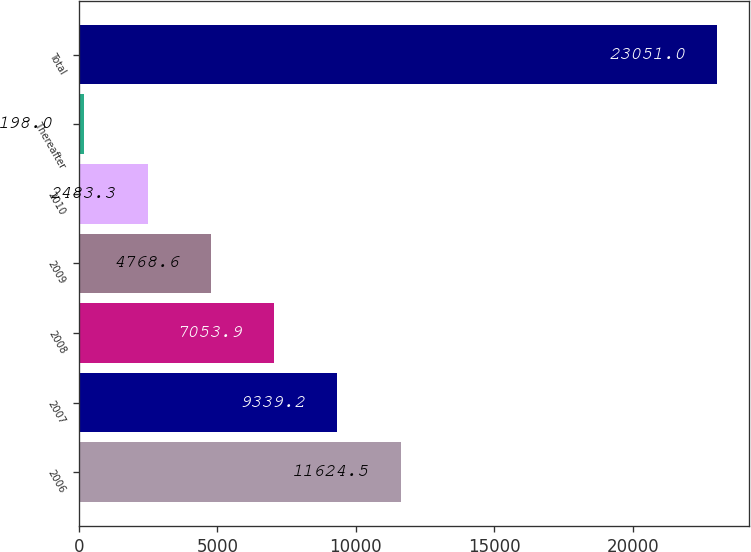<chart> <loc_0><loc_0><loc_500><loc_500><bar_chart><fcel>2006<fcel>2007<fcel>2008<fcel>2009<fcel>2010<fcel>Thereafter<fcel>Total<nl><fcel>11624.5<fcel>9339.2<fcel>7053.9<fcel>4768.6<fcel>2483.3<fcel>198<fcel>23051<nl></chart> 